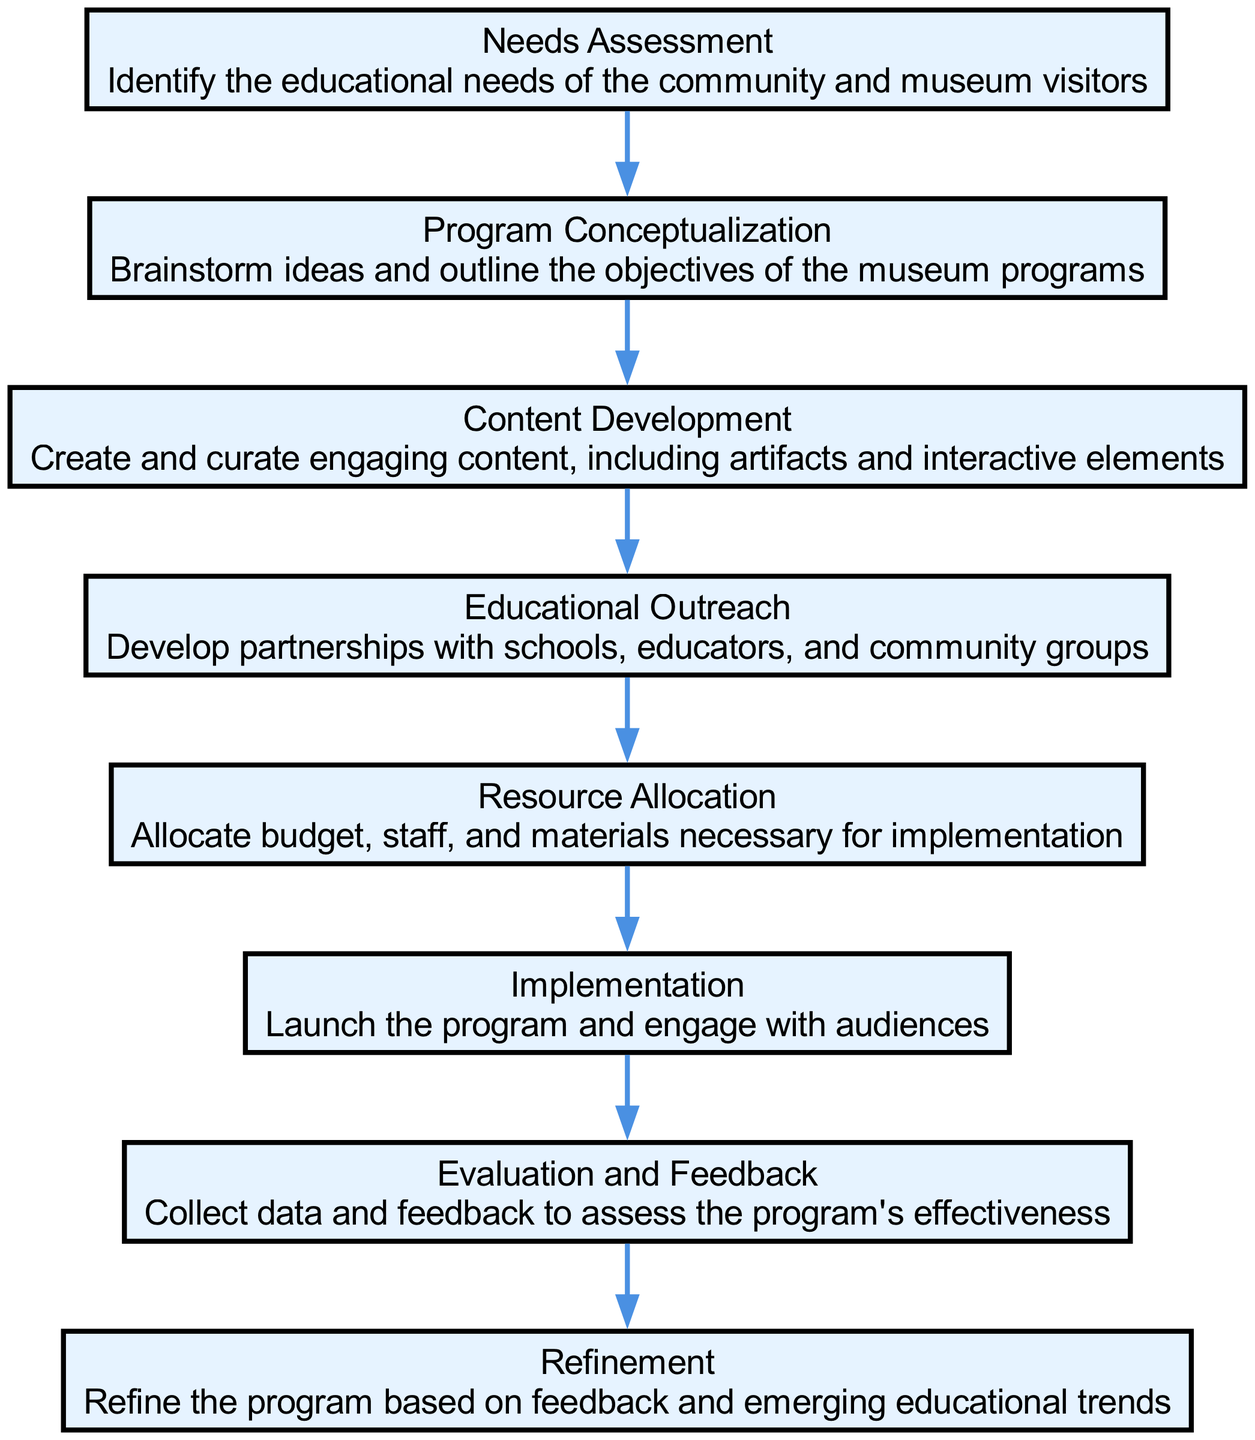What is the first stage in the diagram? The first stage is "Needs Assessment," which is the starting point for developing museum educational programs. It is shown at the top of the diagram and is the first node connected to the next stage.
Answer: Needs Assessment How many stages are present in the diagram? There are eight stages in total represented as nodes in the diagram; each stage corresponds to a part of the program development process.
Answer: Eight Which stage follows Content Development? The stage that follows "Content Development" is "Educational Outreach"; this can be inferred from the directed edge leading from Content Development to Educational Outreach.
Answer: Educational Outreach What is the last stage of the program development process? The last stage is "Refinement," as it is the final node that follows the "Evaluation and Feedback" stage in the sequence of the program development.
Answer: Refinement What are the two consecutive stages after Program Conceptualization? The two consecutive stages following "Program Conceptualization" are "Content Development" and "Educational Outreach," as seen in the sequence of edges connecting these stages.
Answer: Content Development and Educational Outreach What stage requires partnerships development? The stage that necessitates developing partnerships is "Educational Outreach," indicated by its position in the flow where engagement with schools and community groups is highlighted.
Answer: Educational Outreach Which stage is directly linked to Implementation? "Evaluation and Feedback" is directly linked to "Implementation"; the process flows from Implementation to Evaluation and Feedback indicating a feedback loop post-implementation.
Answer: Evaluation and Feedback How does the feedback influence the program? Feedback influences the program by informing the "Refinement" stage, where the program is adjusted based on the collected evaluation data and community needs, thus enhancing its effectiveness.
Answer: Refinement 